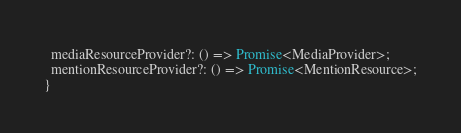Convert code to text. <code><loc_0><loc_0><loc_500><loc_500><_TypeScript_>  mediaResourceProvider?: () => Promise<MediaProvider>;
  mentionResourceProvider?: () => Promise<MentionResource>;
}
</code> 